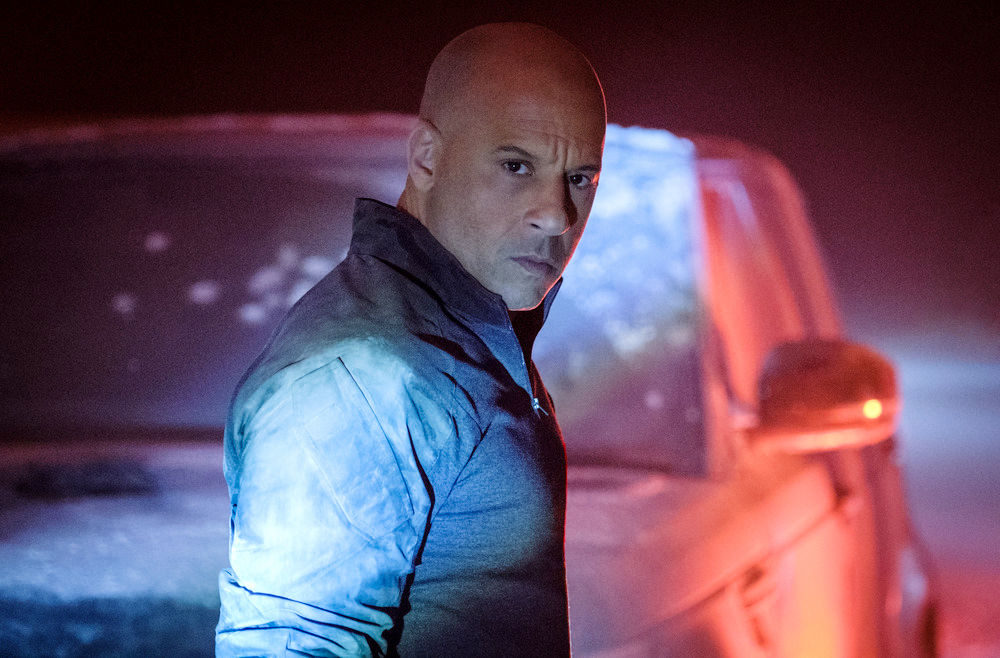Explain the visual content of the image in great detail. In the image, a man is standing near a vehicle in a chilly, dimly lit environment, which possibly suggests a wintery or nocturnal setting. Fog or mist adds a mysterious atmosphere. The man, positioned in a three-quarter stance toward the camera, exudes a serious or intense demeanour. He is wearing a light blue, glossy jacket which captures the ambient light, contrasting with the darker tones of the setting. Behind him, a vehicle with its rear lights gently glowing is partially visible, enhancing the overall moody aesthetic of the photograph. 